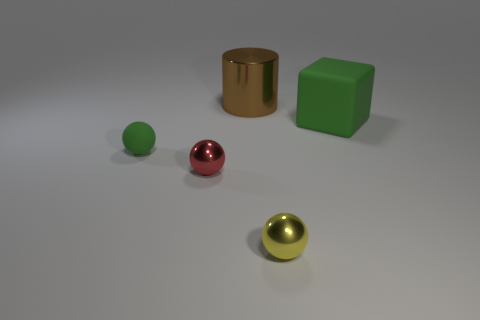What is the material of the yellow thing that is the same shape as the red metal object?
Offer a very short reply. Metal. What is the size of the yellow sphere that is made of the same material as the brown cylinder?
Make the answer very short. Small. Does the thing in front of the small red ball have the same shape as the green matte object left of the yellow sphere?
Offer a terse response. Yes. Does the green rubber object in front of the green block have the same size as the green thing that is on the right side of the brown metallic cylinder?
Offer a very short reply. No. Is the thing on the right side of the yellow sphere made of the same material as the ball to the right of the cylinder?
Make the answer very short. No. What shape is the rubber object that is on the left side of the big object in front of the big brown object?
Provide a succinct answer. Sphere. Are there any tiny red things to the right of the brown shiny thing?
Keep it short and to the point. No. What color is the matte cube that is the same size as the brown cylinder?
Offer a very short reply. Green. How many large blue blocks have the same material as the large brown cylinder?
Ensure brevity in your answer.  0. What number of other things are there of the same size as the red ball?
Your response must be concise. 2. 